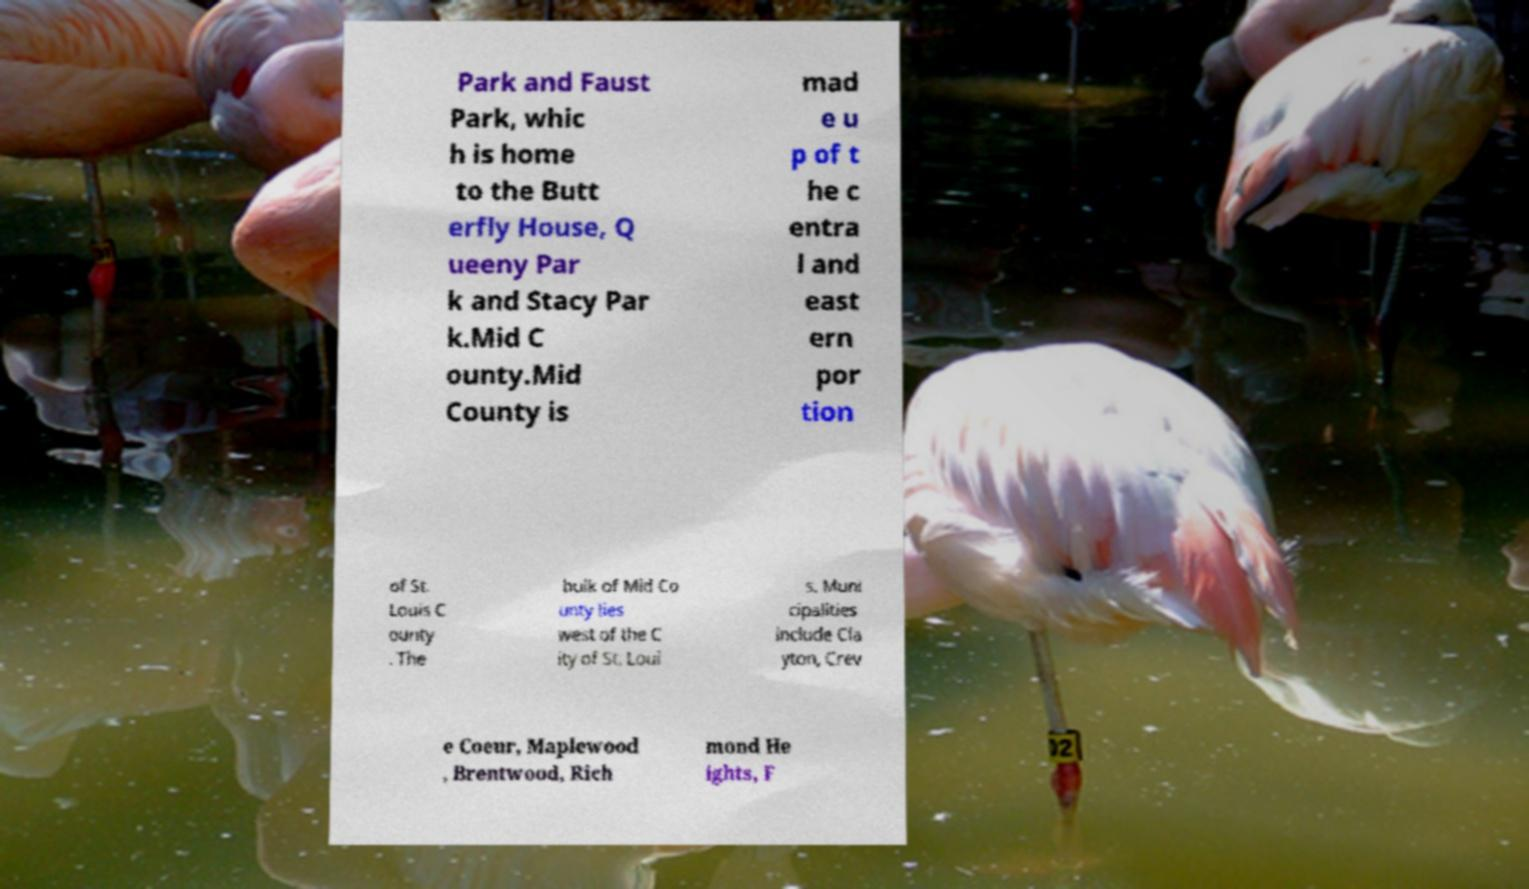There's text embedded in this image that I need extracted. Can you transcribe it verbatim? Park and Faust Park, whic h is home to the Butt erfly House, Q ueeny Par k and Stacy Par k.Mid C ounty.Mid County is mad e u p of t he c entra l and east ern por tion of St. Louis C ounty . The bulk of Mid Co unty lies west of the C ity of St. Loui s. Muni cipalities include Cla yton, Crev e Coeur, Maplewood , Brentwood, Rich mond He ights, F 